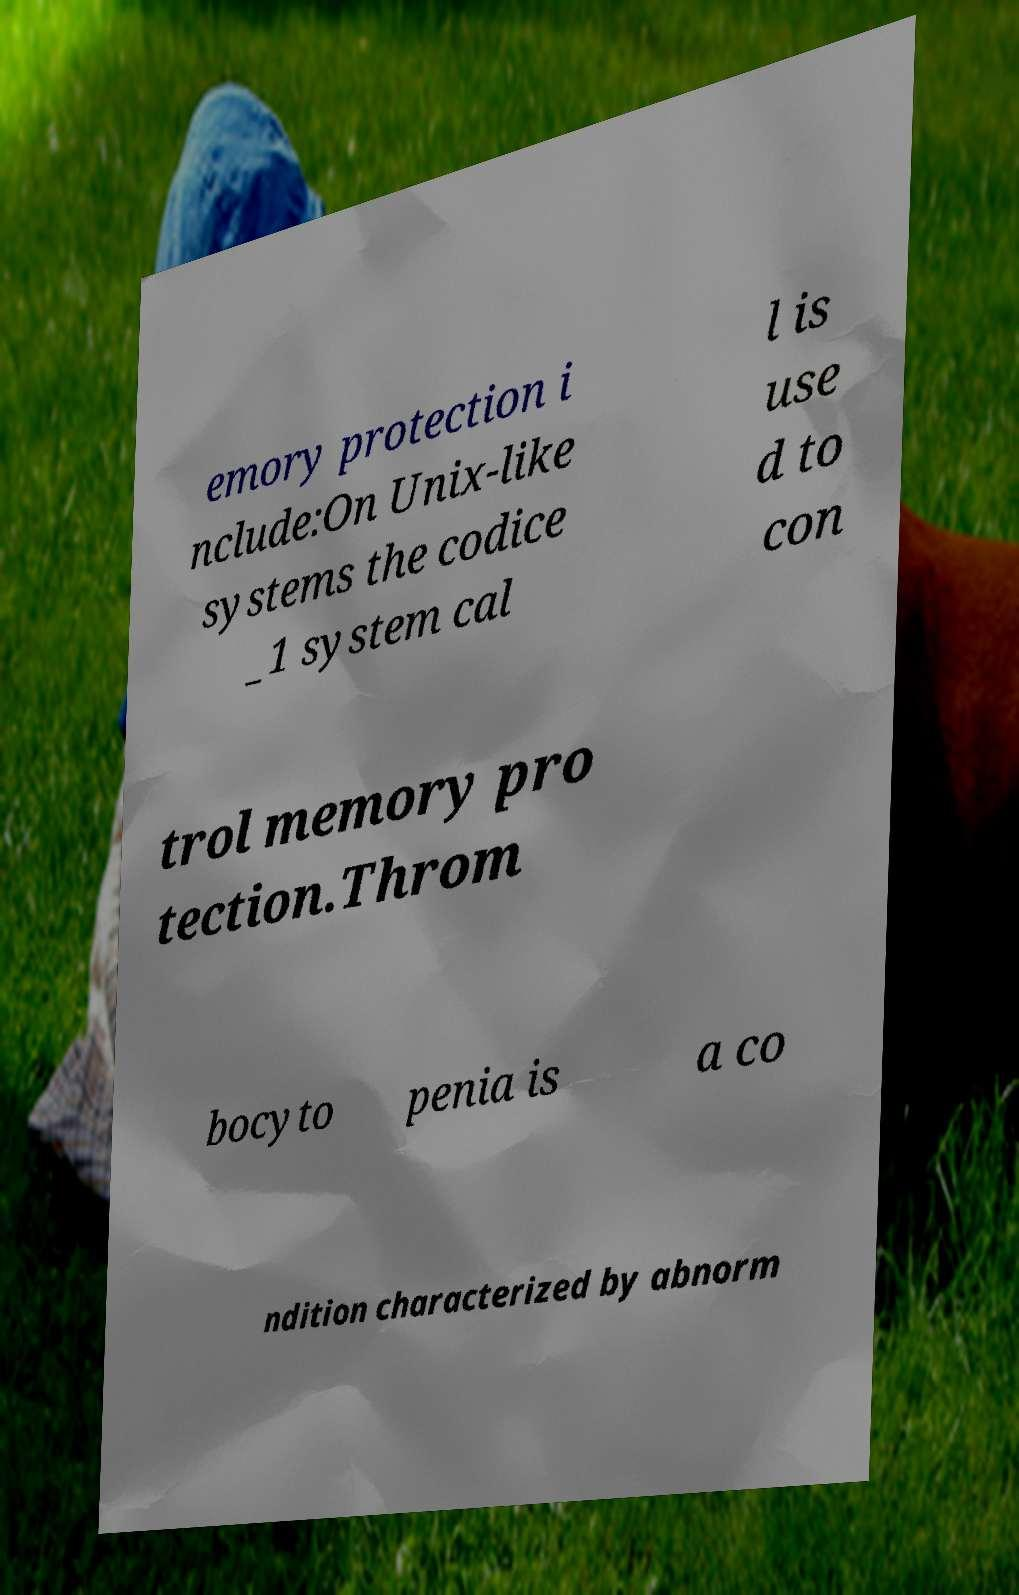Could you extract and type out the text from this image? emory protection i nclude:On Unix-like systems the codice _1 system cal l is use d to con trol memory pro tection.Throm bocyto penia is a co ndition characterized by abnorm 